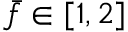<formula> <loc_0><loc_0><loc_500><loc_500>\bar { f } \in [ 1 , 2 ]</formula> 